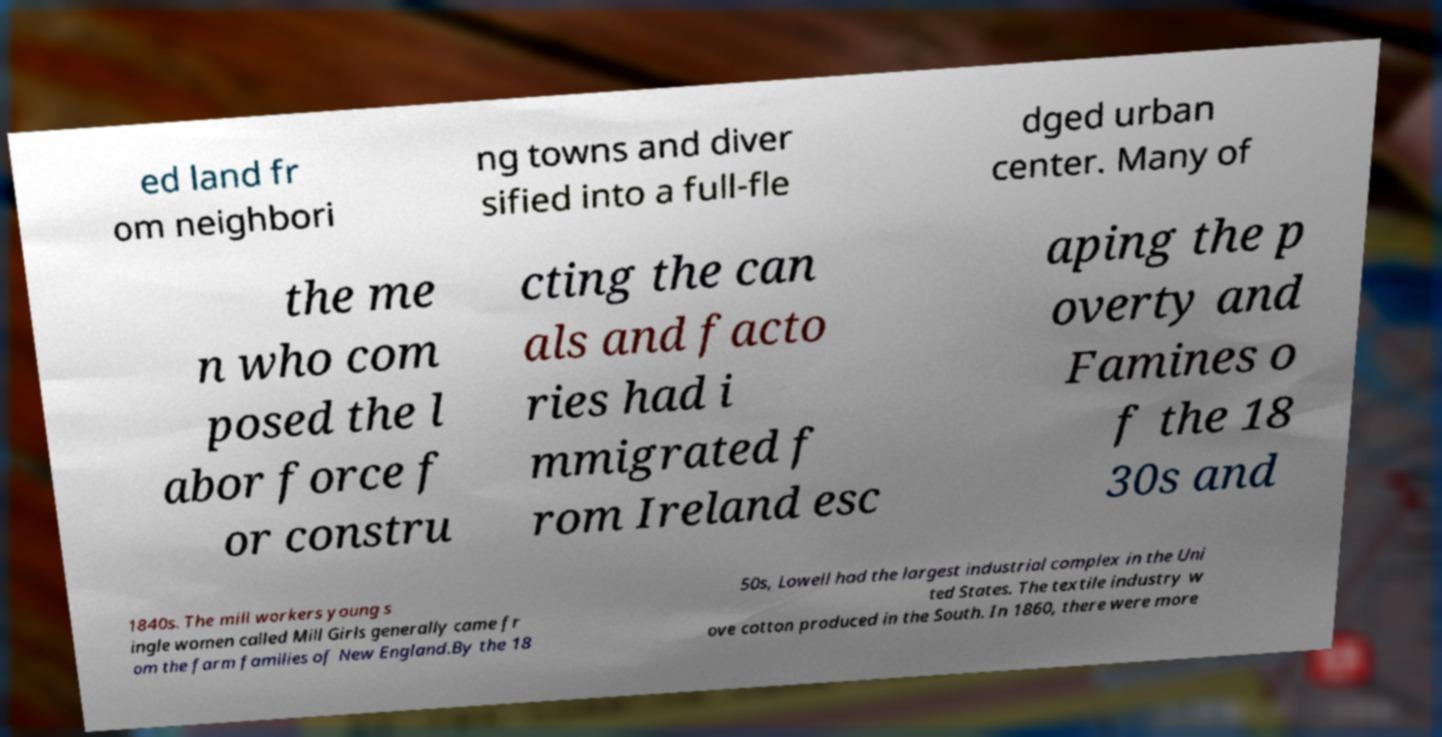Can you read and provide the text displayed in the image?This photo seems to have some interesting text. Can you extract and type it out for me? ed land fr om neighbori ng towns and diver sified into a full-fle dged urban center. Many of the me n who com posed the l abor force f or constru cting the can als and facto ries had i mmigrated f rom Ireland esc aping the p overty and Famines o f the 18 30s and 1840s. The mill workers young s ingle women called Mill Girls generally came fr om the farm families of New England.By the 18 50s, Lowell had the largest industrial complex in the Uni ted States. The textile industry w ove cotton produced in the South. In 1860, there were more 